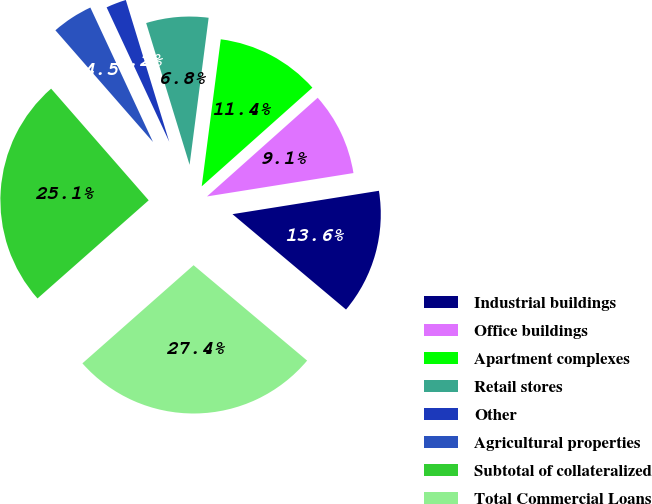<chart> <loc_0><loc_0><loc_500><loc_500><pie_chart><fcel>Industrial buildings<fcel>Office buildings<fcel>Apartment complexes<fcel>Retail stores<fcel>Other<fcel>Agricultural properties<fcel>Subtotal of collateralized<fcel>Total Commercial Loans<nl><fcel>13.64%<fcel>9.07%<fcel>11.36%<fcel>6.78%<fcel>2.21%<fcel>4.49%<fcel>25.08%<fcel>27.37%<nl></chart> 